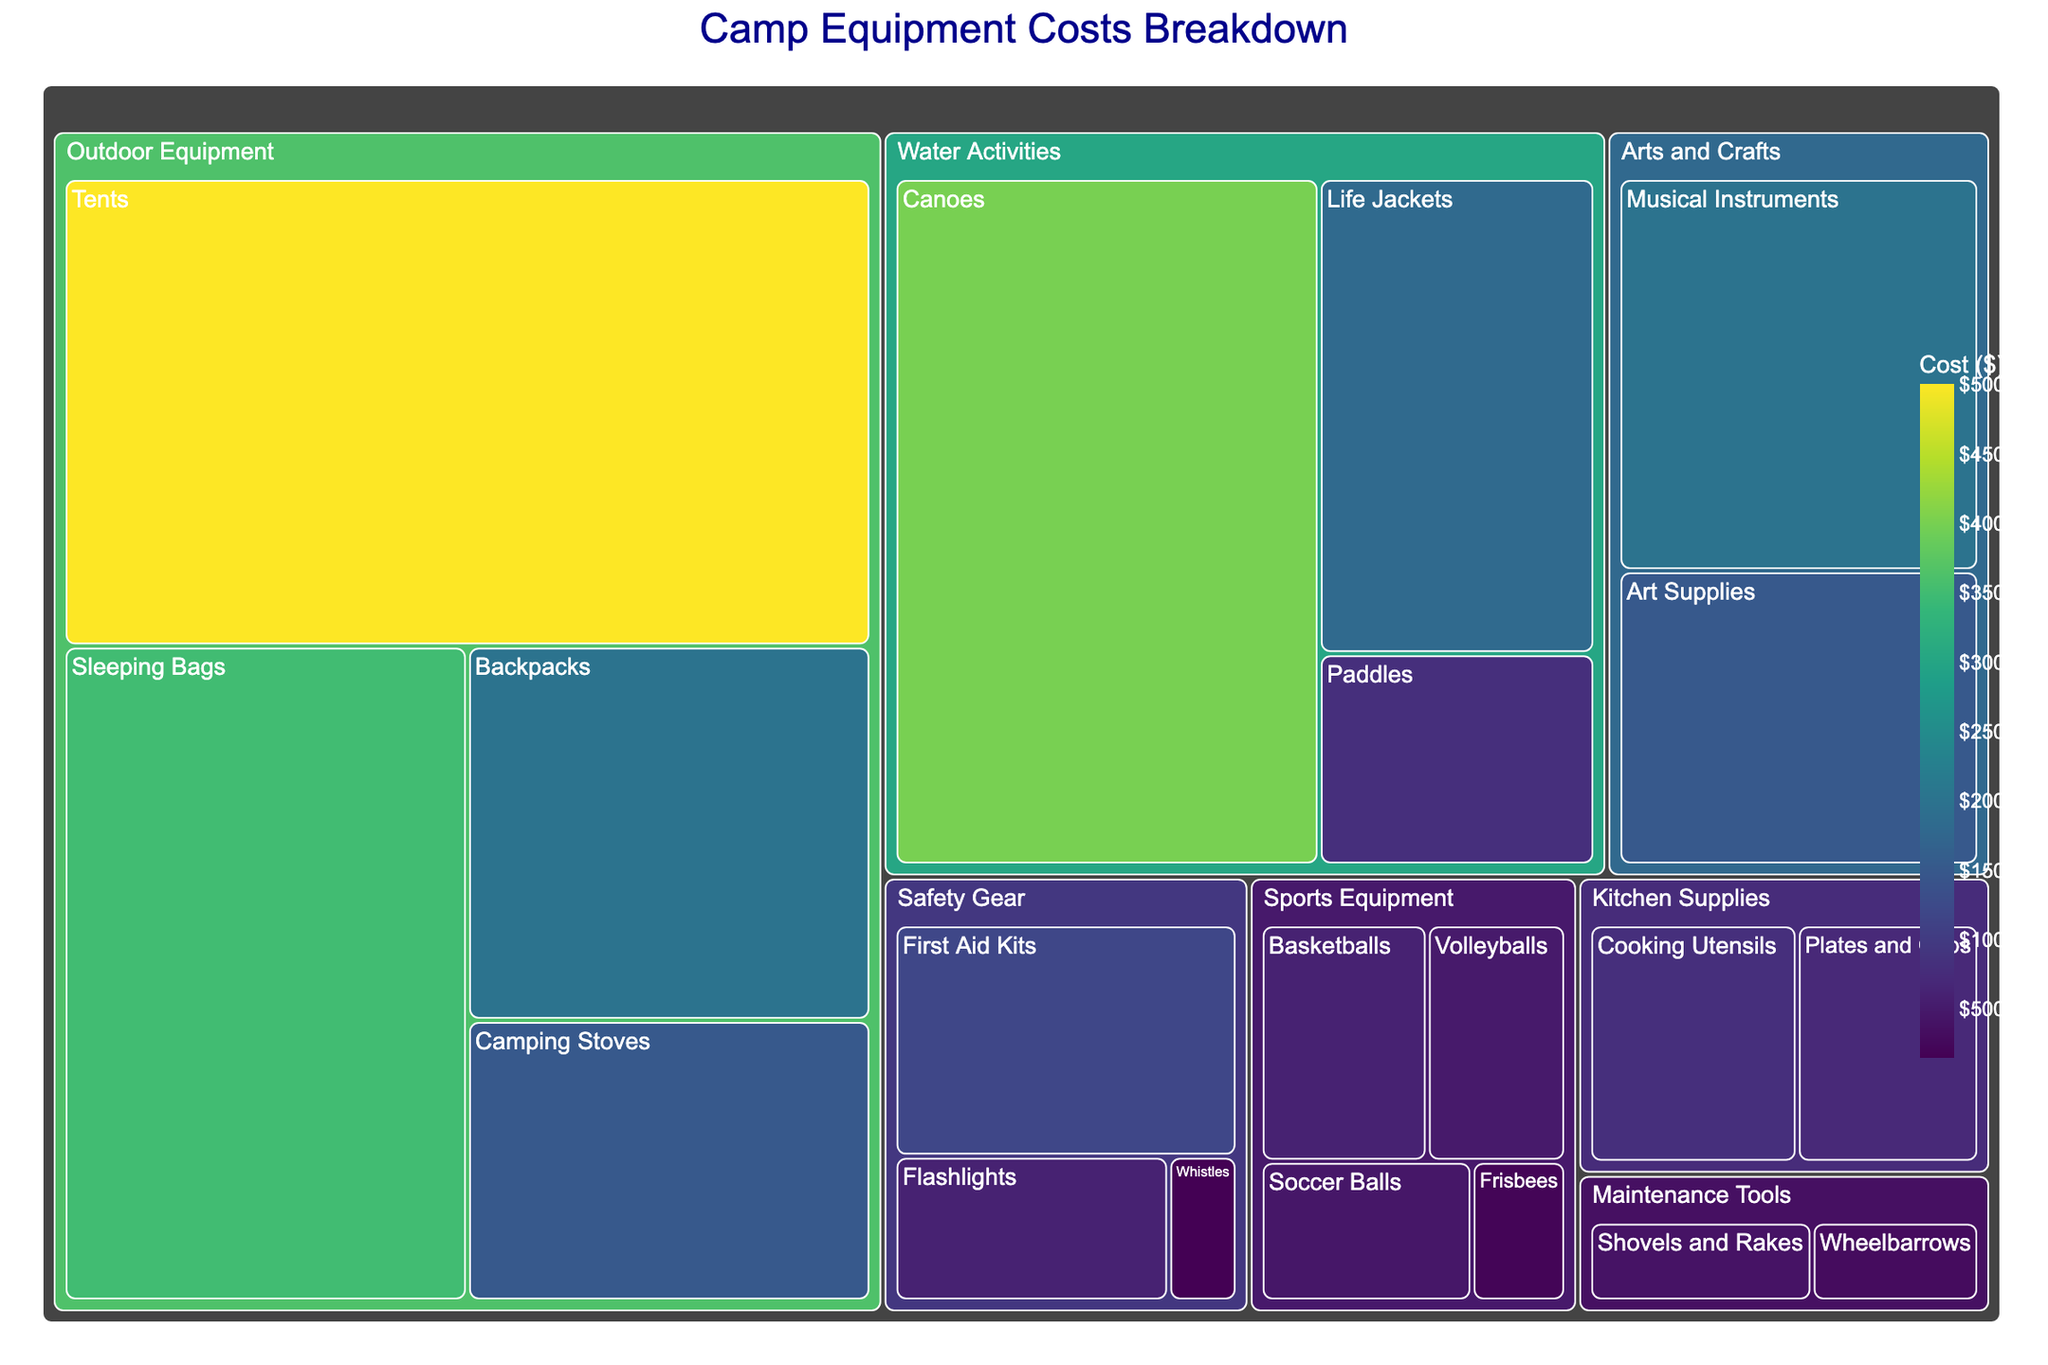What is the title of the treemap? The title is typically located at the top of the treemap and provides a summary of what the treemap represents.
Answer: Camp Equipment Costs Breakdown Which subcategory has the highest cost in the "Outdoor Equipment" category? Look for the subcategory within "Outdoor Equipment" that has the largest section or the highest cost label.
Answer: Tents How much was spent on "Water Activities" in total? Sum the costs of all subcategories under "Water Activities". These include canoes, life jackets, and paddles ($4000 + $1800 + $800).
Answer: $6,600 What is the least expensive subcategory in the "Safety Gear" category? Identify the smallest section or the one with the lowest cost label within the "Safety Gear" category.
Answer: Whistles Compare the costs of "Art Supplies" and "Musical Instruments". Which one is higher and by how much? Check the costs of both subcategories under "Arts and Crafts" and subtract the lower from the higher. "Musical Instruments" cost $2000 and "Art Supplies" cost $1500. Subtract $1500 from $2000.
Answer: Musical Instruments by $500 What is the combined cost of "Sports Equipment" and "Kitchen Supplies"? Add up all subcategory costs under both "Sports Equipment" and "Kitchen Supplies". (Basketballs, Volleyballs, Soccer Balls, Frisbees + Cooking Utensils, Plates and Cups) = ($600 + $500 + $450 + $200) + ($800 + $700).
Answer: $3,250 Which category has a larger total cost: "Maintenance Tools" or "Arts and Crafts"? Sum the subcategory costs within "Maintenance Tools" and "Arts and Crafts" separately, then compare the totals. "Maintenance Tools" costs ($400 + $300) = $700, "Arts and Crafts" costs ($1500 + $2000) = $3500.
Answer: Arts and Crafts Out of "Canoes", "Sleeping Bags", and "First Aid Kits", which has the highest cost? Compare the cost values of "Canoes", "Sleeping Bags", and "First Aid Kits" directly.
Answer: Canoes How is the cost distributed among subcategories in the "Sports Equipment" category? List the costs of all subcategories within "Sports Equipment". These are Basketballs ($600), Volleyballs ($500), Soccer Balls ($450), and Frisbees ($200).
Answer: $600, $500, $450, $200 What would be the new total cost if the budget for "Camping Stoves" increases by $500? Add $500 to the original cost of "Camping Stoves" and calculate the new total cost. "Camping Stoves" original cost is $1500, adding $500 makes it $2000.
Answer: $2,000 